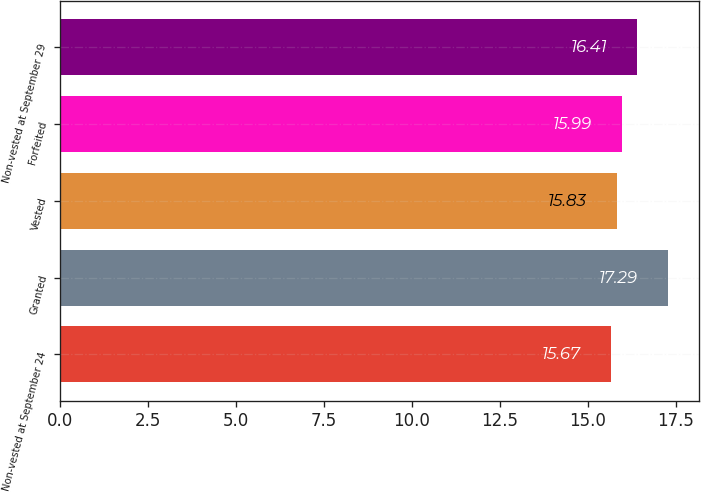Convert chart to OTSL. <chart><loc_0><loc_0><loc_500><loc_500><bar_chart><fcel>Non-vested at September 24<fcel>Granted<fcel>Vested<fcel>Forfeited<fcel>Non-vested at September 29<nl><fcel>15.67<fcel>17.29<fcel>15.83<fcel>15.99<fcel>16.41<nl></chart> 